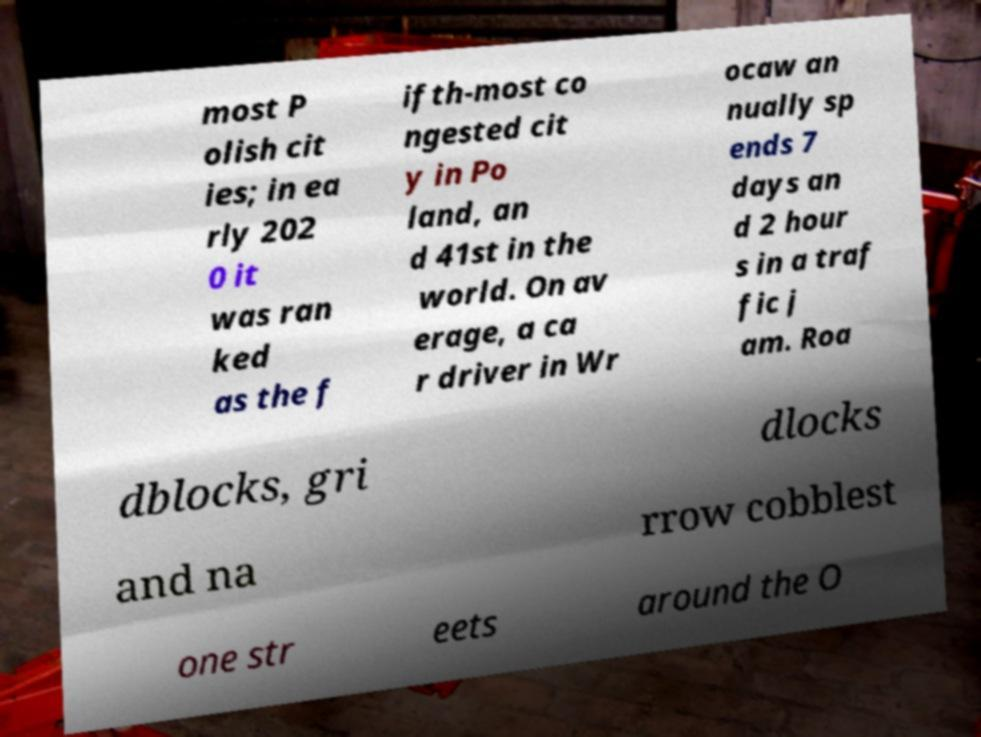What messages or text are displayed in this image? I need them in a readable, typed format. most P olish cit ies; in ea rly 202 0 it was ran ked as the f ifth-most co ngested cit y in Po land, an d 41st in the world. On av erage, a ca r driver in Wr ocaw an nually sp ends 7 days an d 2 hour s in a traf fic j am. Roa dblocks, gri dlocks and na rrow cobblest one str eets around the O 